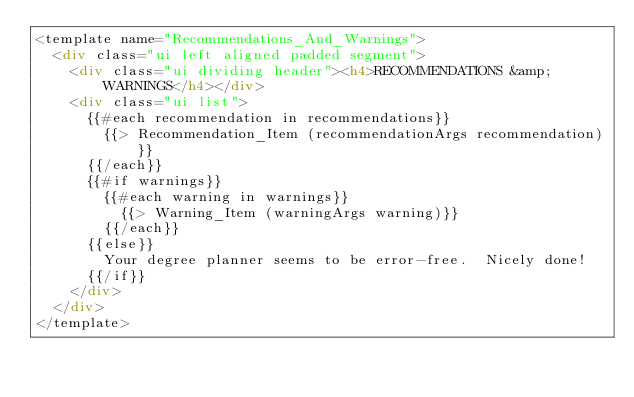<code> <loc_0><loc_0><loc_500><loc_500><_HTML_><template name="Recommendations_And_Warnings">
  <div class="ui left aligned padded segment">
    <div class="ui dividing header"><h4>RECOMMENDATIONS &amp; WARNINGS</h4></div>
    <div class="ui list">
      {{#each recommendation in recommendations}}
        {{> Recommendation_Item (recommendationArgs recommendation)}}
      {{/each}}
      {{#if warnings}}
        {{#each warning in warnings}}
          {{> Warning_Item (warningArgs warning)}}
        {{/each}}
      {{else}}
        Your degree planner seems to be error-free.  Nicely done!
      {{/if}}
    </div>
  </div>
</template></code> 